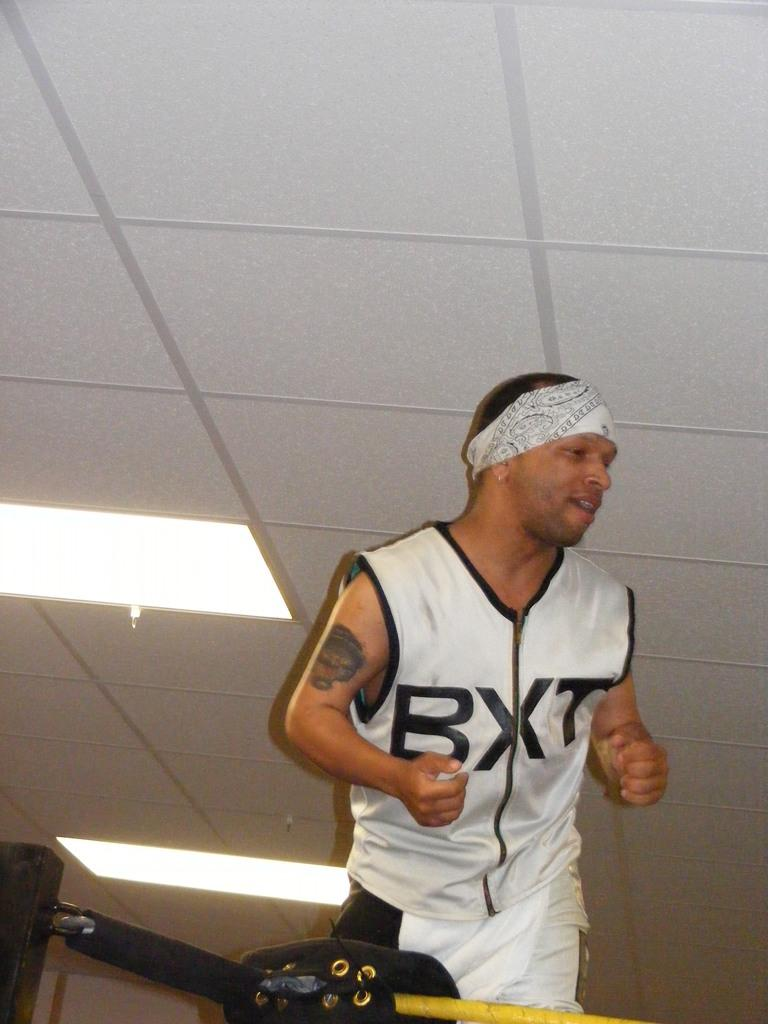<image>
Offer a succinct explanation of the picture presented. Man with bandana and althetic jersey displaying BXT on front. 